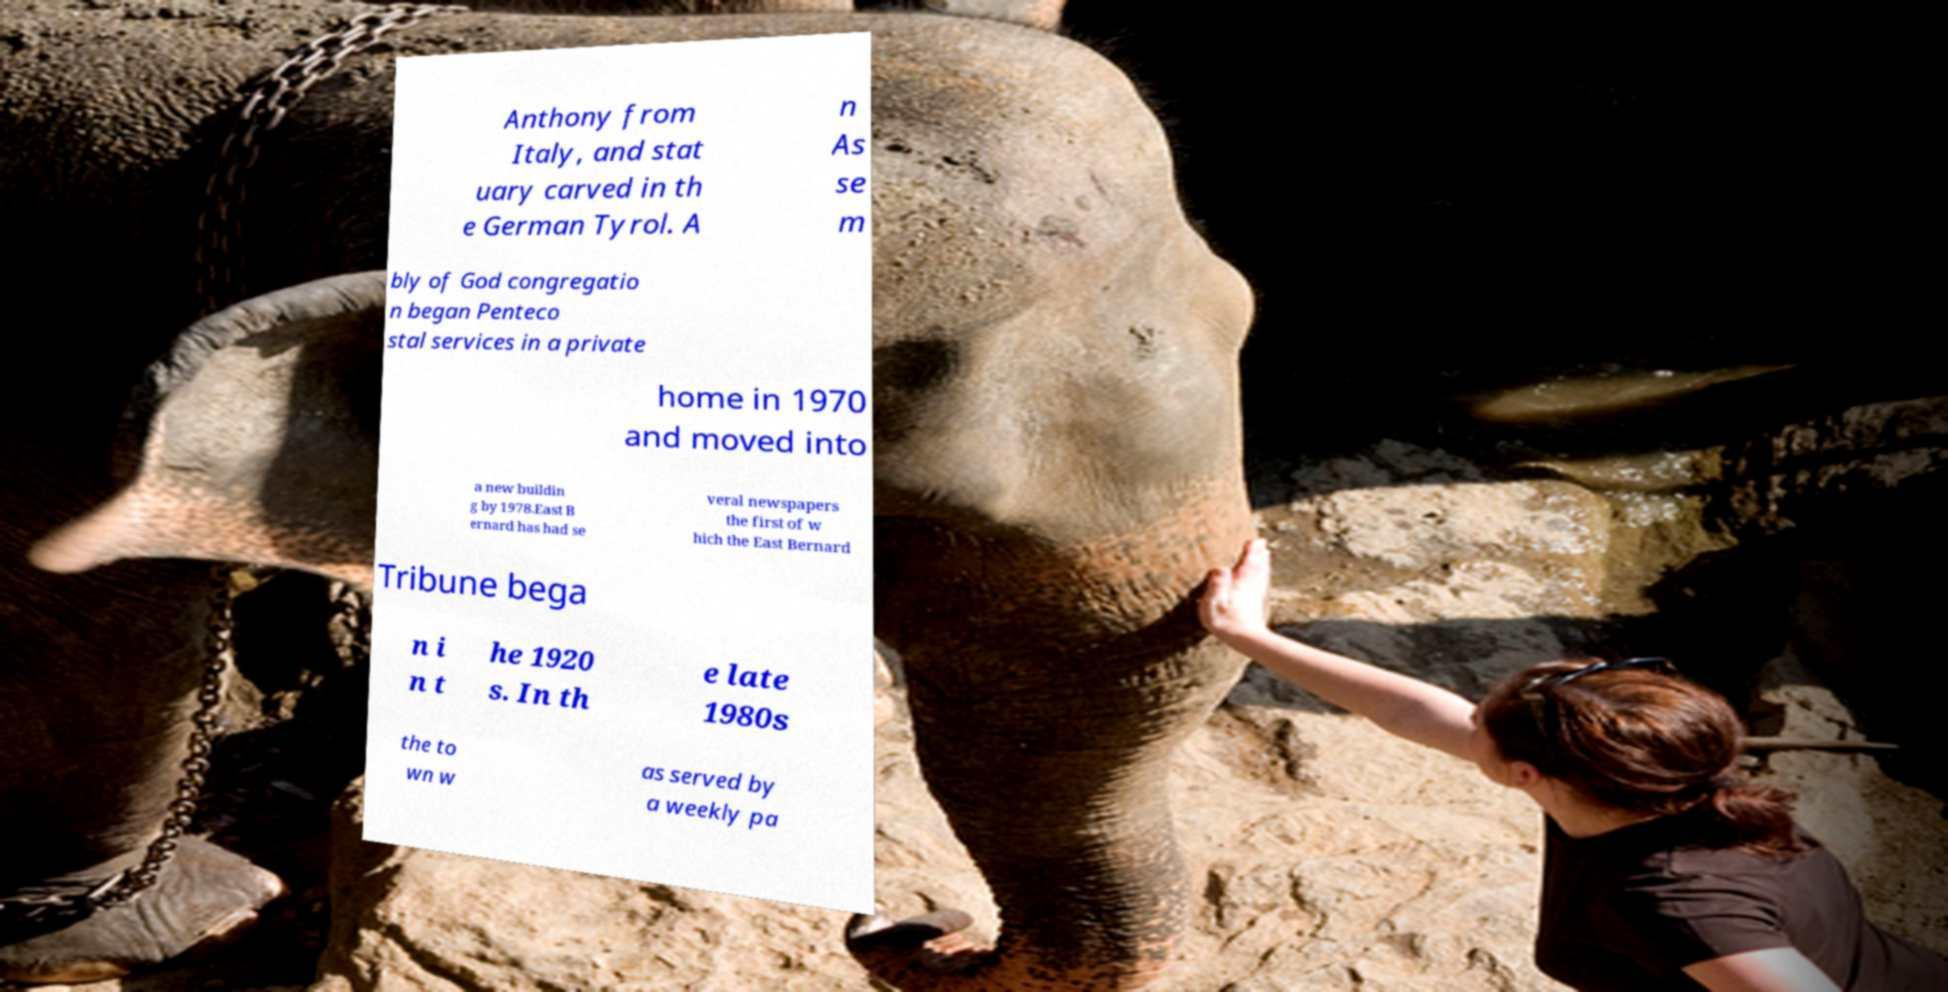Could you extract and type out the text from this image? Anthony from Italy, and stat uary carved in th e German Tyrol. A n As se m bly of God congregatio n began Penteco stal services in a private home in 1970 and moved into a new buildin g by 1978.East B ernard has had se veral newspapers the first of w hich the East Bernard Tribune bega n i n t he 1920 s. In th e late 1980s the to wn w as served by a weekly pa 